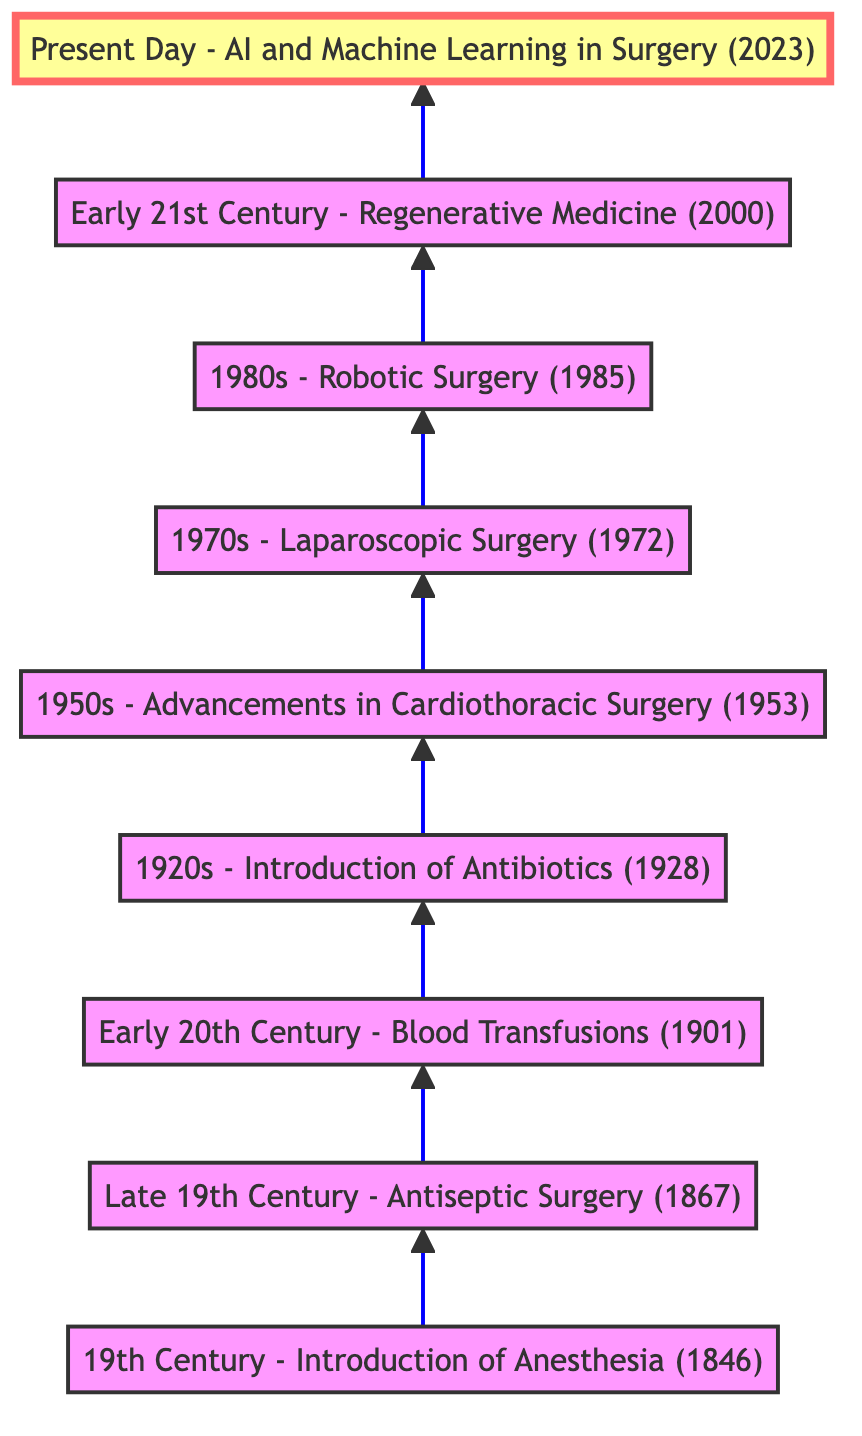What is the earliest surgical technique mentioned in the diagram? The diagram starts with "19th Century - Introduction of Anesthesia," which is the first node in the flow chart and represents the earliest surgical technique.
Answer: 19th Century - Introduction of Anesthesia How many surgical advancements are shown in the flow chart? The diagram lists a total of nine advancements, as there are nine nodes connected in the flow from the bottom to the top.
Answer: 9 What is the year associated with the introduction of antibiotics? The node "1920s - Introduction of Antibiotics" specifies the year as 1928, which is directly indicated in the description of that node.
Answer: 1928 Which surgical advancement followed the introduction of blood transfusions? According to the flow of the diagram, "1920s - Introduction of Antibiotics" follows "Early 20th Century - Blood Transfusions," making it the next advancement after blood transfusions.
Answer: 1920s - Introduction of Antibiotics What development in surgery occurred in the 1980s? The diagram shows "1980s - Robotic Surgery" as the advancement during that decade, which is easily identifiable as the node specifying that timeline.
Answer: 1980s - Robotic Surgery Which technique focuses on minimizing patient recovery times? The node "1970s - Laparoscopic Surgery" explicitly mentions reducing recovery times, making it clear that this technique addresses that concern.
Answer: 1970s - Laparoscopic Surgery How does the introduction of AI relate to previous surgical advancements? The top node "Present Day - AI and Machine Learning in Surgery" indicates the last advancement in the flow chart, suggesting it builds upon all earlier techniques for enhanced precision and decision-making in surgeries.
Answer: Integration of previous techniques What is the significant outcome of Sir Joseph Lister's work? The node "Late 19th Century - Antiseptic Surgery" states that his introduction of antiseptic techniques dramatically reduced infections, highlighting the key outcome related to his contributions.
Answer: Reduced surgical site infections What separates the current surgical practices from those in the early 20th century? The advancements showcased in the flow chart demonstrate a progression from basic surgical techniques like blood transfusions to advanced technologies like AI and machine learning, indicating a significant technological progression over time.
Answer: Technological progression 